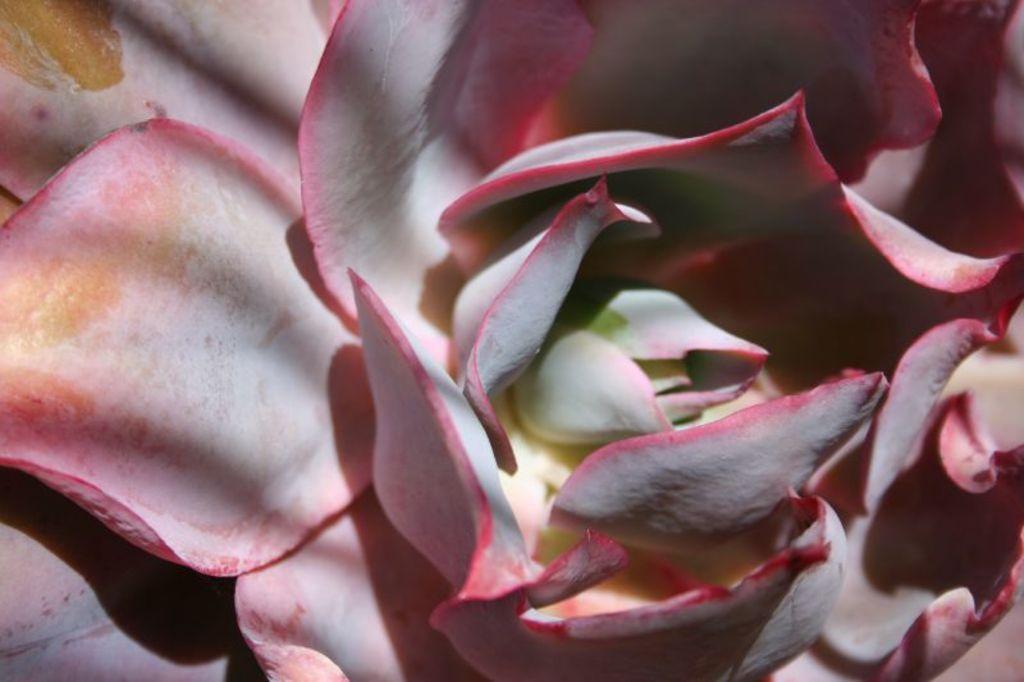How would you summarize this image in a sentence or two? In this image we can see the close view of a flower which is in pink color. 